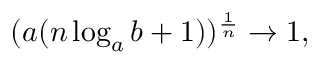<formula> <loc_0><loc_0><loc_500><loc_500>( a ( n \log _ { a } b + 1 ) ) ^ { \frac { 1 } { n } } \to 1 ,</formula> 